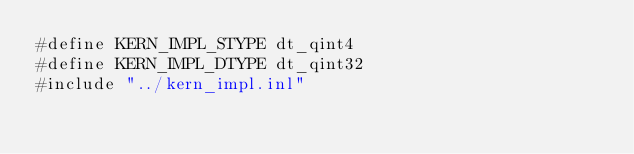Convert code to text. <code><loc_0><loc_0><loc_500><loc_500><_Cuda_>#define KERN_IMPL_STYPE dt_qint4
#define KERN_IMPL_DTYPE dt_qint32
#include "../kern_impl.inl"
</code> 